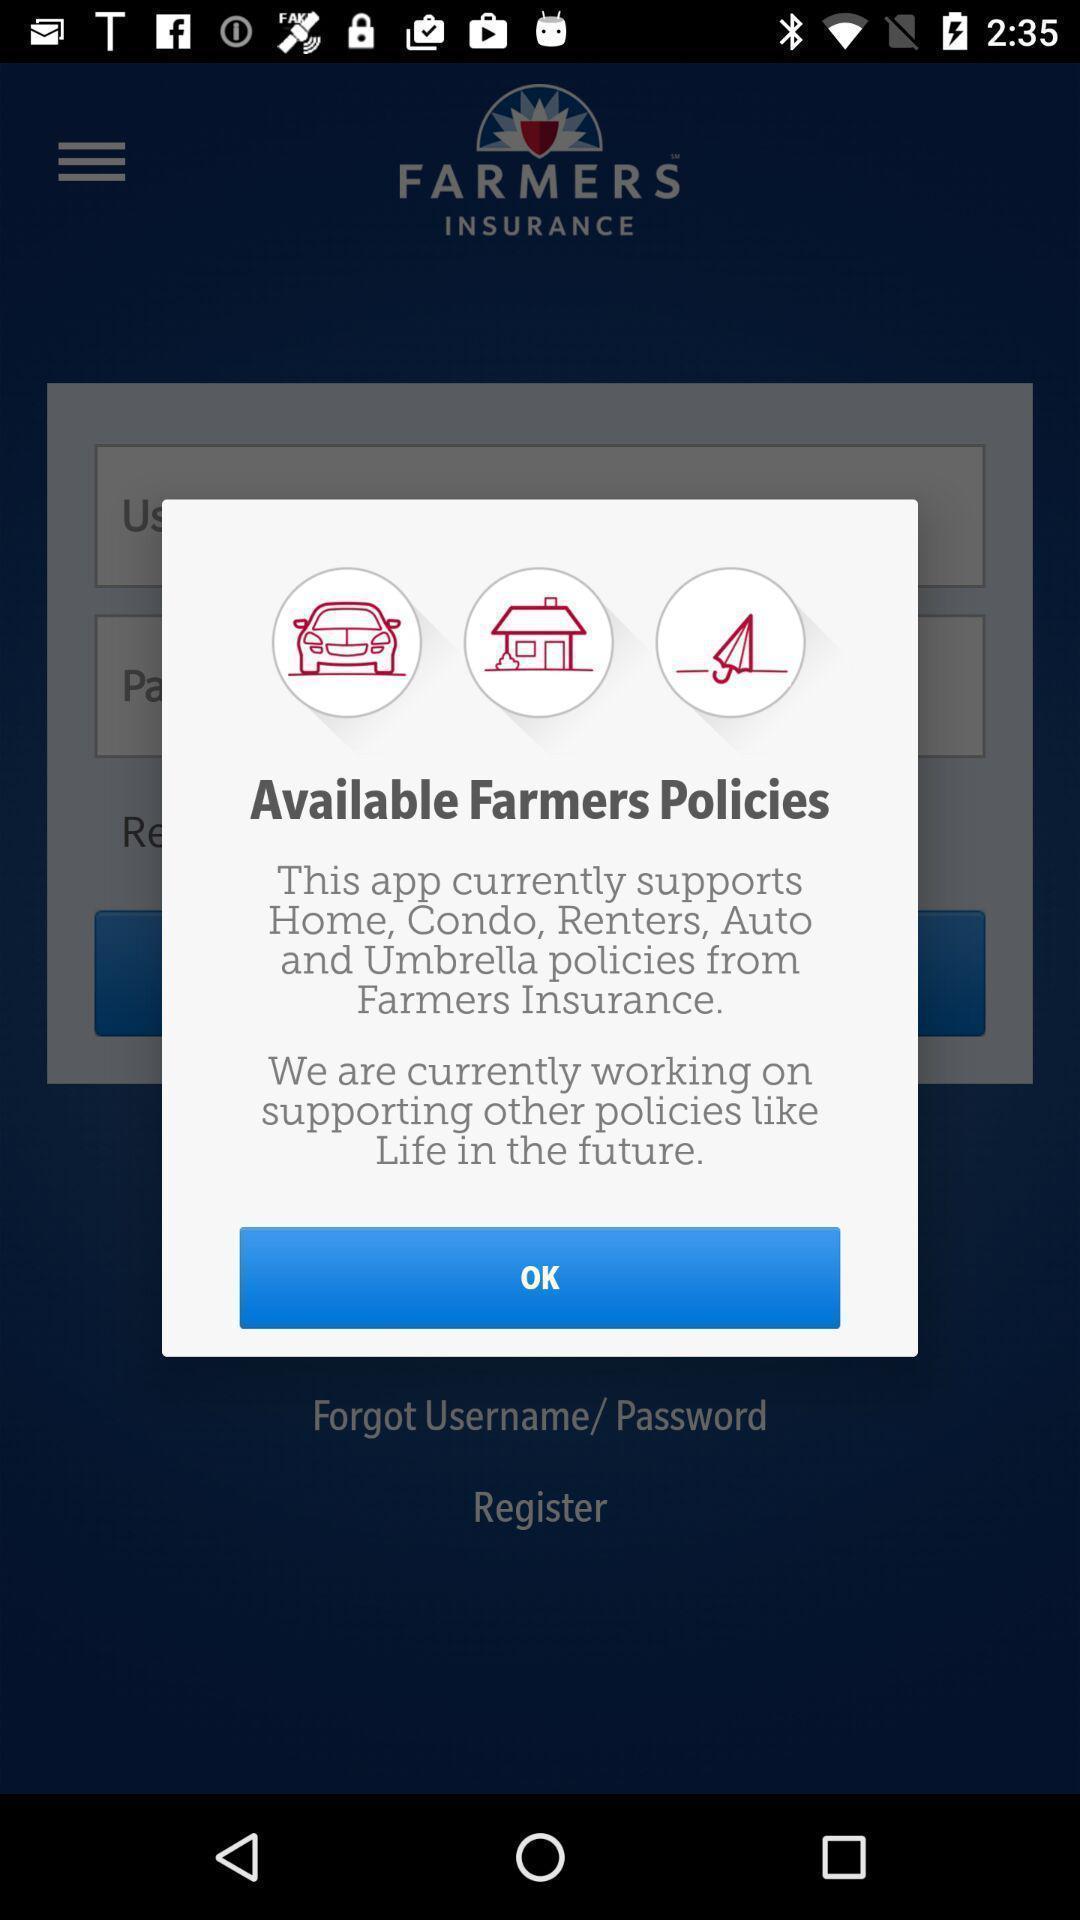Explain what's happening in this screen capture. Pop-up showing information about application. 